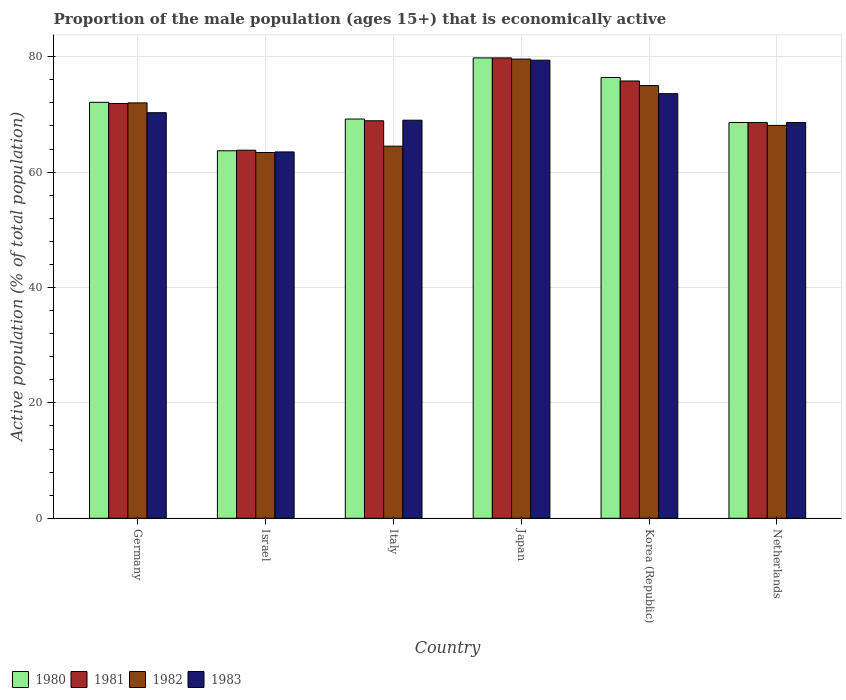How many groups of bars are there?
Provide a short and direct response. 6. How many bars are there on the 6th tick from the right?
Make the answer very short. 4. What is the proportion of the male population that is economically active in 1983 in Germany?
Your answer should be compact. 70.3. Across all countries, what is the maximum proportion of the male population that is economically active in 1980?
Your answer should be compact. 79.8. Across all countries, what is the minimum proportion of the male population that is economically active in 1983?
Your response must be concise. 63.5. In which country was the proportion of the male population that is economically active in 1981 minimum?
Your answer should be very brief. Israel. What is the total proportion of the male population that is economically active in 1981 in the graph?
Offer a very short reply. 428.8. What is the difference between the proportion of the male population that is economically active in 1981 in Italy and that in Korea (Republic)?
Make the answer very short. -6.9. What is the difference between the proportion of the male population that is economically active in 1981 in Italy and the proportion of the male population that is economically active in 1982 in Japan?
Provide a short and direct response. -10.7. What is the average proportion of the male population that is economically active in 1983 per country?
Offer a terse response. 70.73. What is the difference between the proportion of the male population that is economically active of/in 1982 and proportion of the male population that is economically active of/in 1980 in Netherlands?
Ensure brevity in your answer.  -0.5. In how many countries, is the proportion of the male population that is economically active in 1983 greater than 36 %?
Your answer should be compact. 6. What is the ratio of the proportion of the male population that is economically active in 1981 in Israel to that in Italy?
Keep it short and to the point. 0.93. Is the proportion of the male population that is economically active in 1981 in Italy less than that in Netherlands?
Ensure brevity in your answer.  No. What is the difference between the highest and the second highest proportion of the male population that is economically active in 1983?
Your answer should be very brief. 3.3. What is the difference between the highest and the lowest proportion of the male population that is economically active in 1981?
Provide a short and direct response. 16. In how many countries, is the proportion of the male population that is economically active in 1980 greater than the average proportion of the male population that is economically active in 1980 taken over all countries?
Give a very brief answer. 3. Is the sum of the proportion of the male population that is economically active in 1980 in Germany and Italy greater than the maximum proportion of the male population that is economically active in 1983 across all countries?
Give a very brief answer. Yes. What does the 2nd bar from the left in Italy represents?
Provide a succinct answer. 1981. How many bars are there?
Ensure brevity in your answer.  24. Are all the bars in the graph horizontal?
Your response must be concise. No. Does the graph contain any zero values?
Keep it short and to the point. No. Where does the legend appear in the graph?
Your response must be concise. Bottom left. What is the title of the graph?
Ensure brevity in your answer.  Proportion of the male population (ages 15+) that is economically active. What is the label or title of the X-axis?
Offer a very short reply. Country. What is the label or title of the Y-axis?
Offer a very short reply. Active population (% of total population). What is the Active population (% of total population) of 1980 in Germany?
Keep it short and to the point. 72.1. What is the Active population (% of total population) of 1981 in Germany?
Give a very brief answer. 71.9. What is the Active population (% of total population) of 1983 in Germany?
Ensure brevity in your answer.  70.3. What is the Active population (% of total population) in 1980 in Israel?
Ensure brevity in your answer.  63.7. What is the Active population (% of total population) of 1981 in Israel?
Keep it short and to the point. 63.8. What is the Active population (% of total population) in 1982 in Israel?
Offer a very short reply. 63.4. What is the Active population (% of total population) of 1983 in Israel?
Make the answer very short. 63.5. What is the Active population (% of total population) of 1980 in Italy?
Provide a short and direct response. 69.2. What is the Active population (% of total population) of 1981 in Italy?
Your answer should be compact. 68.9. What is the Active population (% of total population) of 1982 in Italy?
Your answer should be very brief. 64.5. What is the Active population (% of total population) of 1980 in Japan?
Your response must be concise. 79.8. What is the Active population (% of total population) of 1981 in Japan?
Your response must be concise. 79.8. What is the Active population (% of total population) in 1982 in Japan?
Make the answer very short. 79.6. What is the Active population (% of total population) in 1983 in Japan?
Ensure brevity in your answer.  79.4. What is the Active population (% of total population) in 1980 in Korea (Republic)?
Ensure brevity in your answer.  76.4. What is the Active population (% of total population) in 1981 in Korea (Republic)?
Your answer should be compact. 75.8. What is the Active population (% of total population) in 1982 in Korea (Republic)?
Your response must be concise. 75. What is the Active population (% of total population) of 1983 in Korea (Republic)?
Your response must be concise. 73.6. What is the Active population (% of total population) of 1980 in Netherlands?
Provide a succinct answer. 68.6. What is the Active population (% of total population) in 1981 in Netherlands?
Make the answer very short. 68.6. What is the Active population (% of total population) in 1982 in Netherlands?
Provide a short and direct response. 68.1. What is the Active population (% of total population) in 1983 in Netherlands?
Provide a short and direct response. 68.6. Across all countries, what is the maximum Active population (% of total population) of 1980?
Your response must be concise. 79.8. Across all countries, what is the maximum Active population (% of total population) in 1981?
Your answer should be compact. 79.8. Across all countries, what is the maximum Active population (% of total population) in 1982?
Your answer should be compact. 79.6. Across all countries, what is the maximum Active population (% of total population) of 1983?
Your answer should be very brief. 79.4. Across all countries, what is the minimum Active population (% of total population) of 1980?
Ensure brevity in your answer.  63.7. Across all countries, what is the minimum Active population (% of total population) of 1981?
Offer a very short reply. 63.8. Across all countries, what is the minimum Active population (% of total population) in 1982?
Your answer should be very brief. 63.4. Across all countries, what is the minimum Active population (% of total population) in 1983?
Provide a succinct answer. 63.5. What is the total Active population (% of total population) of 1980 in the graph?
Your response must be concise. 429.8. What is the total Active population (% of total population) of 1981 in the graph?
Your answer should be very brief. 428.8. What is the total Active population (% of total population) in 1982 in the graph?
Give a very brief answer. 422.6. What is the total Active population (% of total population) of 1983 in the graph?
Provide a short and direct response. 424.4. What is the difference between the Active population (% of total population) of 1981 in Germany and that in Israel?
Your response must be concise. 8.1. What is the difference between the Active population (% of total population) in 1983 in Germany and that in Israel?
Your response must be concise. 6.8. What is the difference between the Active population (% of total population) in 1980 in Germany and that in Italy?
Make the answer very short. 2.9. What is the difference between the Active population (% of total population) in 1982 in Germany and that in Italy?
Ensure brevity in your answer.  7.5. What is the difference between the Active population (% of total population) in 1983 in Germany and that in Italy?
Your response must be concise. 1.3. What is the difference between the Active population (% of total population) in 1981 in Germany and that in Japan?
Offer a terse response. -7.9. What is the difference between the Active population (% of total population) of 1980 in Germany and that in Korea (Republic)?
Provide a short and direct response. -4.3. What is the difference between the Active population (% of total population) of 1981 in Germany and that in Korea (Republic)?
Provide a succinct answer. -3.9. What is the difference between the Active population (% of total population) of 1983 in Germany and that in Korea (Republic)?
Offer a very short reply. -3.3. What is the difference between the Active population (% of total population) in 1981 in Germany and that in Netherlands?
Keep it short and to the point. 3.3. What is the difference between the Active population (% of total population) in 1983 in Israel and that in Italy?
Provide a short and direct response. -5.5. What is the difference between the Active population (% of total population) in 1980 in Israel and that in Japan?
Offer a very short reply. -16.1. What is the difference between the Active population (% of total population) in 1982 in Israel and that in Japan?
Your answer should be very brief. -16.2. What is the difference between the Active population (% of total population) in 1983 in Israel and that in Japan?
Your answer should be very brief. -15.9. What is the difference between the Active population (% of total population) in 1981 in Israel and that in Korea (Republic)?
Your answer should be very brief. -12. What is the difference between the Active population (% of total population) of 1982 in Israel and that in Korea (Republic)?
Provide a short and direct response. -11.6. What is the difference between the Active population (% of total population) in 1980 in Israel and that in Netherlands?
Make the answer very short. -4.9. What is the difference between the Active population (% of total population) of 1982 in Israel and that in Netherlands?
Make the answer very short. -4.7. What is the difference between the Active population (% of total population) of 1982 in Italy and that in Japan?
Ensure brevity in your answer.  -15.1. What is the difference between the Active population (% of total population) of 1981 in Italy and that in Korea (Republic)?
Offer a terse response. -6.9. What is the difference between the Active population (% of total population) of 1982 in Italy and that in Korea (Republic)?
Give a very brief answer. -10.5. What is the difference between the Active population (% of total population) of 1983 in Italy and that in Korea (Republic)?
Your response must be concise. -4.6. What is the difference between the Active population (% of total population) in 1980 in Italy and that in Netherlands?
Your response must be concise. 0.6. What is the difference between the Active population (% of total population) of 1982 in Japan and that in Korea (Republic)?
Your response must be concise. 4.6. What is the difference between the Active population (% of total population) in 1983 in Japan and that in Korea (Republic)?
Your answer should be very brief. 5.8. What is the difference between the Active population (% of total population) in 1980 in Korea (Republic) and that in Netherlands?
Keep it short and to the point. 7.8. What is the difference between the Active population (% of total population) in 1981 in Korea (Republic) and that in Netherlands?
Give a very brief answer. 7.2. What is the difference between the Active population (% of total population) of 1982 in Korea (Republic) and that in Netherlands?
Your response must be concise. 6.9. What is the difference between the Active population (% of total population) of 1980 in Germany and the Active population (% of total population) of 1981 in Israel?
Your answer should be very brief. 8.3. What is the difference between the Active population (% of total population) in 1980 in Germany and the Active population (% of total population) in 1982 in Israel?
Offer a terse response. 8.7. What is the difference between the Active population (% of total population) of 1981 in Germany and the Active population (% of total population) of 1983 in Israel?
Ensure brevity in your answer.  8.4. What is the difference between the Active population (% of total population) of 1982 in Germany and the Active population (% of total population) of 1983 in Israel?
Ensure brevity in your answer.  8.5. What is the difference between the Active population (% of total population) in 1980 in Germany and the Active population (% of total population) in 1981 in Italy?
Offer a very short reply. 3.2. What is the difference between the Active population (% of total population) of 1981 in Germany and the Active population (% of total population) of 1982 in Italy?
Your response must be concise. 7.4. What is the difference between the Active population (% of total population) of 1981 in Germany and the Active population (% of total population) of 1983 in Italy?
Offer a very short reply. 2.9. What is the difference between the Active population (% of total population) of 1980 in Germany and the Active population (% of total population) of 1981 in Japan?
Give a very brief answer. -7.7. What is the difference between the Active population (% of total population) of 1980 in Germany and the Active population (% of total population) of 1983 in Japan?
Provide a short and direct response. -7.3. What is the difference between the Active population (% of total population) of 1982 in Germany and the Active population (% of total population) of 1983 in Japan?
Offer a very short reply. -7.4. What is the difference between the Active population (% of total population) in 1980 in Germany and the Active population (% of total population) in 1981 in Korea (Republic)?
Ensure brevity in your answer.  -3.7. What is the difference between the Active population (% of total population) of 1980 in Germany and the Active population (% of total population) of 1983 in Korea (Republic)?
Your response must be concise. -1.5. What is the difference between the Active population (% of total population) of 1981 in Germany and the Active population (% of total population) of 1982 in Korea (Republic)?
Offer a terse response. -3.1. What is the difference between the Active population (% of total population) of 1981 in Germany and the Active population (% of total population) of 1983 in Korea (Republic)?
Provide a short and direct response. -1.7. What is the difference between the Active population (% of total population) in 1982 in Germany and the Active population (% of total population) in 1983 in Korea (Republic)?
Give a very brief answer. -1.6. What is the difference between the Active population (% of total population) of 1980 in Germany and the Active population (% of total population) of 1981 in Netherlands?
Give a very brief answer. 3.5. What is the difference between the Active population (% of total population) of 1981 in Germany and the Active population (% of total population) of 1982 in Netherlands?
Keep it short and to the point. 3.8. What is the difference between the Active population (% of total population) of 1981 in Germany and the Active population (% of total population) of 1983 in Netherlands?
Ensure brevity in your answer.  3.3. What is the difference between the Active population (% of total population) in 1982 in Germany and the Active population (% of total population) in 1983 in Netherlands?
Offer a terse response. 3.4. What is the difference between the Active population (% of total population) of 1980 in Israel and the Active population (% of total population) of 1981 in Italy?
Give a very brief answer. -5.2. What is the difference between the Active population (% of total population) in 1980 in Israel and the Active population (% of total population) in 1983 in Italy?
Your answer should be compact. -5.3. What is the difference between the Active population (% of total population) in 1981 in Israel and the Active population (% of total population) in 1982 in Italy?
Your response must be concise. -0.7. What is the difference between the Active population (% of total population) in 1982 in Israel and the Active population (% of total population) in 1983 in Italy?
Offer a terse response. -5.6. What is the difference between the Active population (% of total population) of 1980 in Israel and the Active population (% of total population) of 1981 in Japan?
Give a very brief answer. -16.1. What is the difference between the Active population (% of total population) of 1980 in Israel and the Active population (% of total population) of 1982 in Japan?
Give a very brief answer. -15.9. What is the difference between the Active population (% of total population) in 1980 in Israel and the Active population (% of total population) in 1983 in Japan?
Your answer should be compact. -15.7. What is the difference between the Active population (% of total population) of 1981 in Israel and the Active population (% of total population) of 1982 in Japan?
Your answer should be compact. -15.8. What is the difference between the Active population (% of total population) in 1981 in Israel and the Active population (% of total population) in 1983 in Japan?
Give a very brief answer. -15.6. What is the difference between the Active population (% of total population) of 1982 in Israel and the Active population (% of total population) of 1983 in Japan?
Offer a very short reply. -16. What is the difference between the Active population (% of total population) of 1980 in Israel and the Active population (% of total population) of 1981 in Korea (Republic)?
Your answer should be very brief. -12.1. What is the difference between the Active population (% of total population) of 1981 in Israel and the Active population (% of total population) of 1983 in Korea (Republic)?
Make the answer very short. -9.8. What is the difference between the Active population (% of total population) of 1982 in Israel and the Active population (% of total population) of 1983 in Korea (Republic)?
Provide a short and direct response. -10.2. What is the difference between the Active population (% of total population) in 1980 in Israel and the Active population (% of total population) in 1981 in Netherlands?
Offer a very short reply. -4.9. What is the difference between the Active population (% of total population) of 1980 in Israel and the Active population (% of total population) of 1982 in Netherlands?
Make the answer very short. -4.4. What is the difference between the Active population (% of total population) of 1980 in Israel and the Active population (% of total population) of 1983 in Netherlands?
Your answer should be very brief. -4.9. What is the difference between the Active population (% of total population) in 1981 in Israel and the Active population (% of total population) in 1983 in Netherlands?
Keep it short and to the point. -4.8. What is the difference between the Active population (% of total population) of 1980 in Italy and the Active population (% of total population) of 1981 in Japan?
Provide a short and direct response. -10.6. What is the difference between the Active population (% of total population) of 1980 in Italy and the Active population (% of total population) of 1982 in Japan?
Make the answer very short. -10.4. What is the difference between the Active population (% of total population) of 1982 in Italy and the Active population (% of total population) of 1983 in Japan?
Ensure brevity in your answer.  -14.9. What is the difference between the Active population (% of total population) of 1980 in Italy and the Active population (% of total population) of 1981 in Korea (Republic)?
Offer a terse response. -6.6. What is the difference between the Active population (% of total population) of 1981 in Italy and the Active population (% of total population) of 1983 in Korea (Republic)?
Make the answer very short. -4.7. What is the difference between the Active population (% of total population) of 1982 in Italy and the Active population (% of total population) of 1983 in Korea (Republic)?
Give a very brief answer. -9.1. What is the difference between the Active population (% of total population) in 1980 in Japan and the Active population (% of total population) in 1981 in Korea (Republic)?
Provide a short and direct response. 4. What is the difference between the Active population (% of total population) of 1980 in Japan and the Active population (% of total population) of 1982 in Korea (Republic)?
Offer a terse response. 4.8. What is the difference between the Active population (% of total population) of 1981 in Japan and the Active population (% of total population) of 1982 in Korea (Republic)?
Offer a terse response. 4.8. What is the difference between the Active population (% of total population) of 1981 in Japan and the Active population (% of total population) of 1983 in Korea (Republic)?
Provide a succinct answer. 6.2. What is the difference between the Active population (% of total population) in 1982 in Japan and the Active population (% of total population) in 1983 in Korea (Republic)?
Your response must be concise. 6. What is the difference between the Active population (% of total population) of 1980 in Japan and the Active population (% of total population) of 1981 in Netherlands?
Offer a terse response. 11.2. What is the difference between the Active population (% of total population) in 1980 in Japan and the Active population (% of total population) in 1983 in Netherlands?
Your answer should be very brief. 11.2. What is the difference between the Active population (% of total population) in 1981 in Japan and the Active population (% of total population) in 1982 in Netherlands?
Provide a short and direct response. 11.7. What is the difference between the Active population (% of total population) in 1981 in Korea (Republic) and the Active population (% of total population) in 1982 in Netherlands?
Ensure brevity in your answer.  7.7. What is the difference between the Active population (% of total population) in 1981 in Korea (Republic) and the Active population (% of total population) in 1983 in Netherlands?
Provide a succinct answer. 7.2. What is the average Active population (% of total population) of 1980 per country?
Your answer should be compact. 71.63. What is the average Active population (% of total population) in 1981 per country?
Your response must be concise. 71.47. What is the average Active population (% of total population) of 1982 per country?
Provide a short and direct response. 70.43. What is the average Active population (% of total population) in 1983 per country?
Give a very brief answer. 70.73. What is the difference between the Active population (% of total population) in 1980 and Active population (% of total population) in 1982 in Germany?
Provide a succinct answer. 0.1. What is the difference between the Active population (% of total population) of 1982 and Active population (% of total population) of 1983 in Germany?
Your answer should be compact. 1.7. What is the difference between the Active population (% of total population) in 1980 and Active population (% of total population) in 1981 in Israel?
Offer a very short reply. -0.1. What is the difference between the Active population (% of total population) of 1980 and Active population (% of total population) of 1983 in Israel?
Keep it short and to the point. 0.2. What is the difference between the Active population (% of total population) of 1982 and Active population (% of total population) of 1983 in Israel?
Keep it short and to the point. -0.1. What is the difference between the Active population (% of total population) of 1980 and Active population (% of total population) of 1981 in Italy?
Keep it short and to the point. 0.3. What is the difference between the Active population (% of total population) in 1981 and Active population (% of total population) in 1983 in Italy?
Provide a short and direct response. -0.1. What is the difference between the Active population (% of total population) of 1982 and Active population (% of total population) of 1983 in Italy?
Your response must be concise. -4.5. What is the difference between the Active population (% of total population) of 1981 and Active population (% of total population) of 1983 in Japan?
Keep it short and to the point. 0.4. What is the difference between the Active population (% of total population) of 1980 and Active population (% of total population) of 1982 in Korea (Republic)?
Offer a terse response. 1.4. What is the difference between the Active population (% of total population) of 1982 and Active population (% of total population) of 1983 in Korea (Republic)?
Make the answer very short. 1.4. What is the difference between the Active population (% of total population) of 1980 and Active population (% of total population) of 1983 in Netherlands?
Offer a terse response. 0. What is the difference between the Active population (% of total population) in 1981 and Active population (% of total population) in 1982 in Netherlands?
Offer a terse response. 0.5. What is the ratio of the Active population (% of total population) in 1980 in Germany to that in Israel?
Offer a very short reply. 1.13. What is the ratio of the Active population (% of total population) in 1981 in Germany to that in Israel?
Provide a succinct answer. 1.13. What is the ratio of the Active population (% of total population) in 1982 in Germany to that in Israel?
Make the answer very short. 1.14. What is the ratio of the Active population (% of total population) in 1983 in Germany to that in Israel?
Provide a succinct answer. 1.11. What is the ratio of the Active population (% of total population) in 1980 in Germany to that in Italy?
Offer a very short reply. 1.04. What is the ratio of the Active population (% of total population) in 1981 in Germany to that in Italy?
Offer a very short reply. 1.04. What is the ratio of the Active population (% of total population) in 1982 in Germany to that in Italy?
Provide a short and direct response. 1.12. What is the ratio of the Active population (% of total population) in 1983 in Germany to that in Italy?
Ensure brevity in your answer.  1.02. What is the ratio of the Active population (% of total population) in 1980 in Germany to that in Japan?
Keep it short and to the point. 0.9. What is the ratio of the Active population (% of total population) in 1981 in Germany to that in Japan?
Your response must be concise. 0.9. What is the ratio of the Active population (% of total population) of 1982 in Germany to that in Japan?
Your answer should be very brief. 0.9. What is the ratio of the Active population (% of total population) of 1983 in Germany to that in Japan?
Provide a short and direct response. 0.89. What is the ratio of the Active population (% of total population) in 1980 in Germany to that in Korea (Republic)?
Ensure brevity in your answer.  0.94. What is the ratio of the Active population (% of total population) of 1981 in Germany to that in Korea (Republic)?
Give a very brief answer. 0.95. What is the ratio of the Active population (% of total population) in 1983 in Germany to that in Korea (Republic)?
Offer a very short reply. 0.96. What is the ratio of the Active population (% of total population) in 1980 in Germany to that in Netherlands?
Ensure brevity in your answer.  1.05. What is the ratio of the Active population (% of total population) in 1981 in Germany to that in Netherlands?
Your answer should be very brief. 1.05. What is the ratio of the Active population (% of total population) in 1982 in Germany to that in Netherlands?
Your response must be concise. 1.06. What is the ratio of the Active population (% of total population) in 1983 in Germany to that in Netherlands?
Ensure brevity in your answer.  1.02. What is the ratio of the Active population (% of total population) in 1980 in Israel to that in Italy?
Ensure brevity in your answer.  0.92. What is the ratio of the Active population (% of total population) in 1981 in Israel to that in Italy?
Make the answer very short. 0.93. What is the ratio of the Active population (% of total population) in 1982 in Israel to that in Italy?
Provide a succinct answer. 0.98. What is the ratio of the Active population (% of total population) of 1983 in Israel to that in Italy?
Your answer should be compact. 0.92. What is the ratio of the Active population (% of total population) in 1980 in Israel to that in Japan?
Your answer should be very brief. 0.8. What is the ratio of the Active population (% of total population) of 1981 in Israel to that in Japan?
Make the answer very short. 0.8. What is the ratio of the Active population (% of total population) of 1982 in Israel to that in Japan?
Make the answer very short. 0.8. What is the ratio of the Active population (% of total population) in 1983 in Israel to that in Japan?
Offer a very short reply. 0.8. What is the ratio of the Active population (% of total population) in 1980 in Israel to that in Korea (Republic)?
Keep it short and to the point. 0.83. What is the ratio of the Active population (% of total population) in 1981 in Israel to that in Korea (Republic)?
Your answer should be very brief. 0.84. What is the ratio of the Active population (% of total population) of 1982 in Israel to that in Korea (Republic)?
Keep it short and to the point. 0.85. What is the ratio of the Active population (% of total population) of 1983 in Israel to that in Korea (Republic)?
Make the answer very short. 0.86. What is the ratio of the Active population (% of total population) of 1983 in Israel to that in Netherlands?
Your answer should be compact. 0.93. What is the ratio of the Active population (% of total population) of 1980 in Italy to that in Japan?
Provide a short and direct response. 0.87. What is the ratio of the Active population (% of total population) in 1981 in Italy to that in Japan?
Your answer should be very brief. 0.86. What is the ratio of the Active population (% of total population) in 1982 in Italy to that in Japan?
Your answer should be very brief. 0.81. What is the ratio of the Active population (% of total population) of 1983 in Italy to that in Japan?
Give a very brief answer. 0.87. What is the ratio of the Active population (% of total population) of 1980 in Italy to that in Korea (Republic)?
Provide a short and direct response. 0.91. What is the ratio of the Active population (% of total population) of 1981 in Italy to that in Korea (Republic)?
Offer a very short reply. 0.91. What is the ratio of the Active population (% of total population) of 1982 in Italy to that in Korea (Republic)?
Keep it short and to the point. 0.86. What is the ratio of the Active population (% of total population) in 1980 in Italy to that in Netherlands?
Your answer should be very brief. 1.01. What is the ratio of the Active population (% of total population) of 1981 in Italy to that in Netherlands?
Give a very brief answer. 1. What is the ratio of the Active population (% of total population) of 1982 in Italy to that in Netherlands?
Your answer should be very brief. 0.95. What is the ratio of the Active population (% of total population) of 1983 in Italy to that in Netherlands?
Make the answer very short. 1.01. What is the ratio of the Active population (% of total population) in 1980 in Japan to that in Korea (Republic)?
Give a very brief answer. 1.04. What is the ratio of the Active population (% of total population) of 1981 in Japan to that in Korea (Republic)?
Make the answer very short. 1.05. What is the ratio of the Active population (% of total population) in 1982 in Japan to that in Korea (Republic)?
Your response must be concise. 1.06. What is the ratio of the Active population (% of total population) of 1983 in Japan to that in Korea (Republic)?
Offer a very short reply. 1.08. What is the ratio of the Active population (% of total population) in 1980 in Japan to that in Netherlands?
Make the answer very short. 1.16. What is the ratio of the Active population (% of total population) of 1981 in Japan to that in Netherlands?
Provide a short and direct response. 1.16. What is the ratio of the Active population (% of total population) of 1982 in Japan to that in Netherlands?
Your response must be concise. 1.17. What is the ratio of the Active population (% of total population) of 1983 in Japan to that in Netherlands?
Your response must be concise. 1.16. What is the ratio of the Active population (% of total population) in 1980 in Korea (Republic) to that in Netherlands?
Offer a very short reply. 1.11. What is the ratio of the Active population (% of total population) in 1981 in Korea (Republic) to that in Netherlands?
Ensure brevity in your answer.  1.1. What is the ratio of the Active population (% of total population) of 1982 in Korea (Republic) to that in Netherlands?
Ensure brevity in your answer.  1.1. What is the ratio of the Active population (% of total population) in 1983 in Korea (Republic) to that in Netherlands?
Offer a very short reply. 1.07. What is the difference between the highest and the second highest Active population (% of total population) of 1980?
Provide a succinct answer. 3.4. What is the difference between the highest and the second highest Active population (% of total population) of 1981?
Ensure brevity in your answer.  4. What is the difference between the highest and the second highest Active population (% of total population) of 1982?
Provide a succinct answer. 4.6. What is the difference between the highest and the lowest Active population (% of total population) of 1980?
Offer a terse response. 16.1. What is the difference between the highest and the lowest Active population (% of total population) in 1981?
Your response must be concise. 16. What is the difference between the highest and the lowest Active population (% of total population) in 1982?
Keep it short and to the point. 16.2. What is the difference between the highest and the lowest Active population (% of total population) of 1983?
Ensure brevity in your answer.  15.9. 